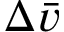Convert formula to latex. <formula><loc_0><loc_0><loc_500><loc_500>\Delta \bar { v }</formula> 